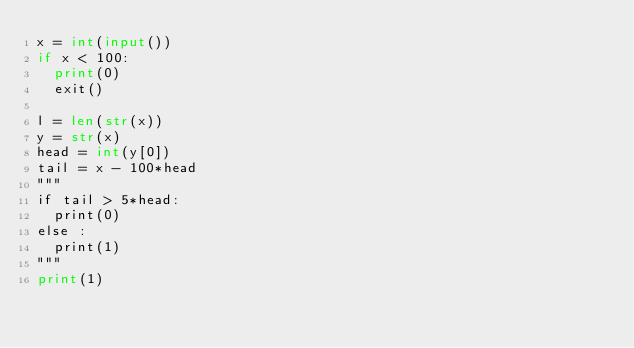<code> <loc_0><loc_0><loc_500><loc_500><_Python_>x = int(input())
if x < 100:
	print(0)
	exit()

l = len(str(x))
y = str(x)
head = int(y[0])
tail = x - 100*head
"""
if tail > 5*head:
	print(0)
else :
	print(1)
"""
print(1)</code> 